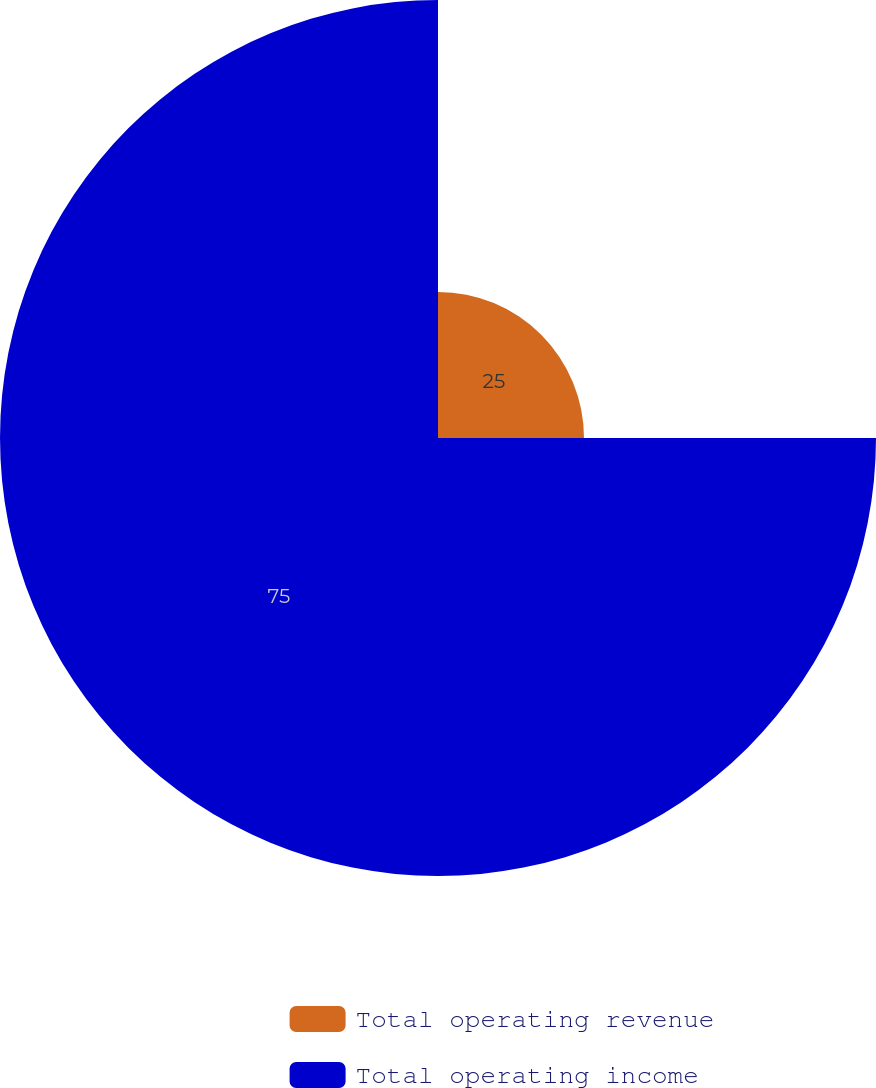Convert chart. <chart><loc_0><loc_0><loc_500><loc_500><pie_chart><fcel>Total operating revenue<fcel>Total operating income<nl><fcel>25.0%<fcel>75.0%<nl></chart> 